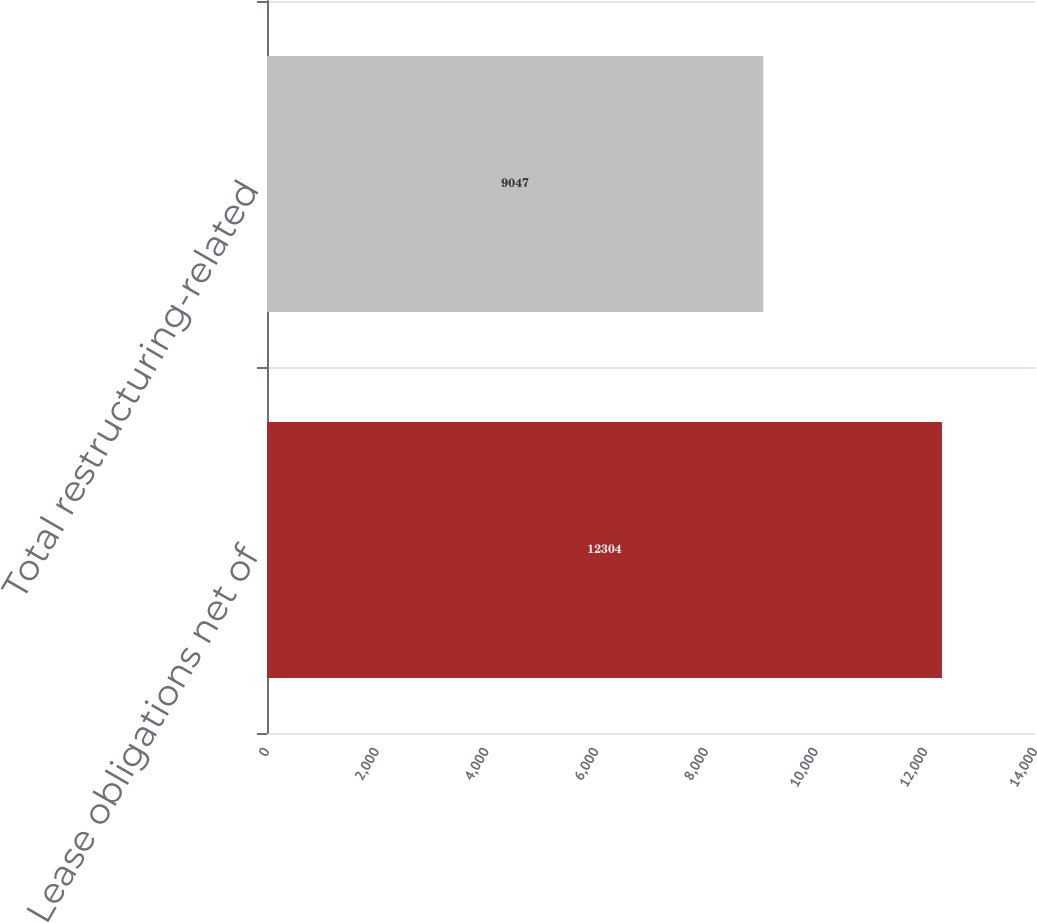Convert chart. <chart><loc_0><loc_0><loc_500><loc_500><bar_chart><fcel>Lease obligations net of<fcel>Total restructuring-related<nl><fcel>12304<fcel>9047<nl></chart> 